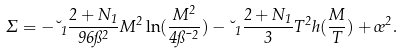<formula> <loc_0><loc_0><loc_500><loc_500>\Sigma = - \lambda _ { 1 } \frac { 2 + N _ { 1 } } { 9 6 \pi ^ { 2 } } M ^ { 2 } \ln ( \frac { M ^ { 2 } } { 4 \pi \mu ^ { 2 } } ) - \lambda _ { 1 } \frac { 2 + N _ { 1 } } { 3 } T ^ { 2 } h ( \frac { M } { T } ) + \sigma ^ { 2 } .</formula> 